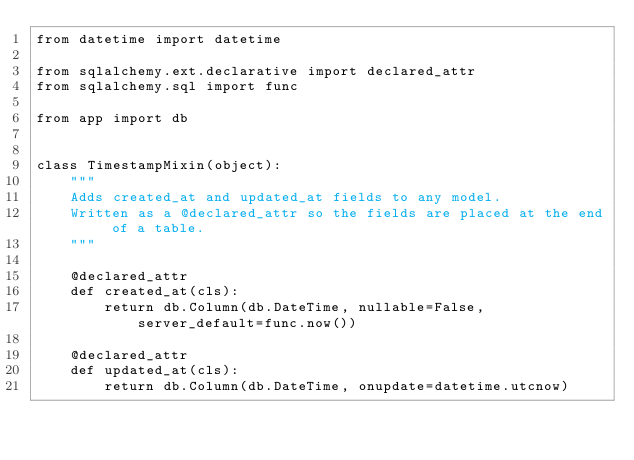<code> <loc_0><loc_0><loc_500><loc_500><_Python_>from datetime import datetime

from sqlalchemy.ext.declarative import declared_attr
from sqlalchemy.sql import func

from app import db


class TimestampMixin(object):
    """
    Adds created_at and updated_at fields to any model.
    Written as a @declared_attr so the fields are placed at the end of a table.
    """

    @declared_attr
    def created_at(cls):
        return db.Column(db.DateTime, nullable=False, server_default=func.now())

    @declared_attr
    def updated_at(cls):
        return db.Column(db.DateTime, onupdate=datetime.utcnow)
</code> 